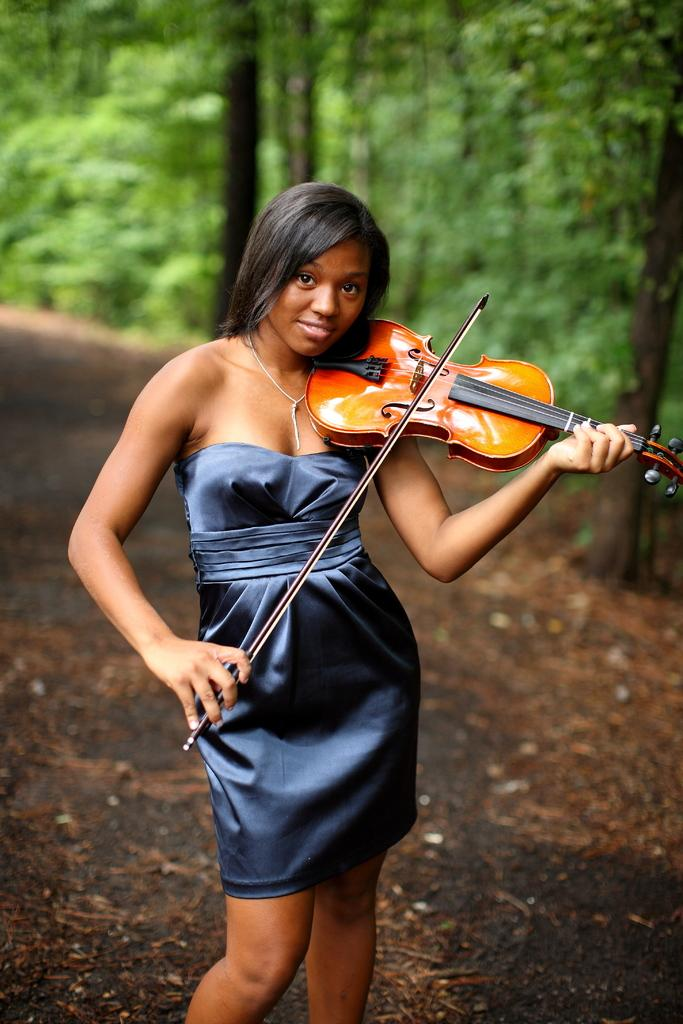Who is the main subject in the image? There is a woman in the image. What is the woman wearing? The woman is wearing a blue dress. What is the woman doing in the image? The woman is standing and playing the violin. What can be seen in the background of the image? There are trees in the background of the image. What type of boundary can be seen in the image? There is no boundary present in the image. What connection does the woman have with the trees in the background? The woman is not connected to the trees in the background; she is playing the violin while standing in front of them. 